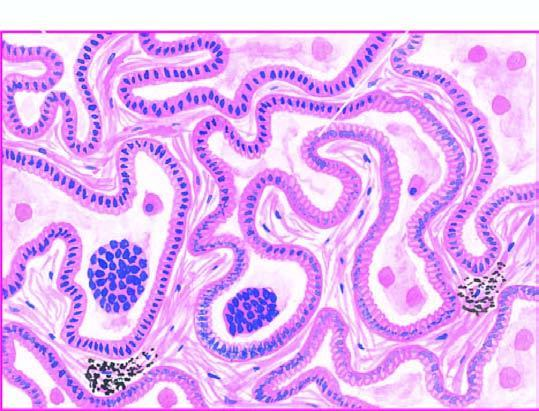what are lined by cuboidal to tall columnar and mucin-secreting tumour cells with papillary growth pattern?
Answer the question using a single word or phrase. Alveolar walls 